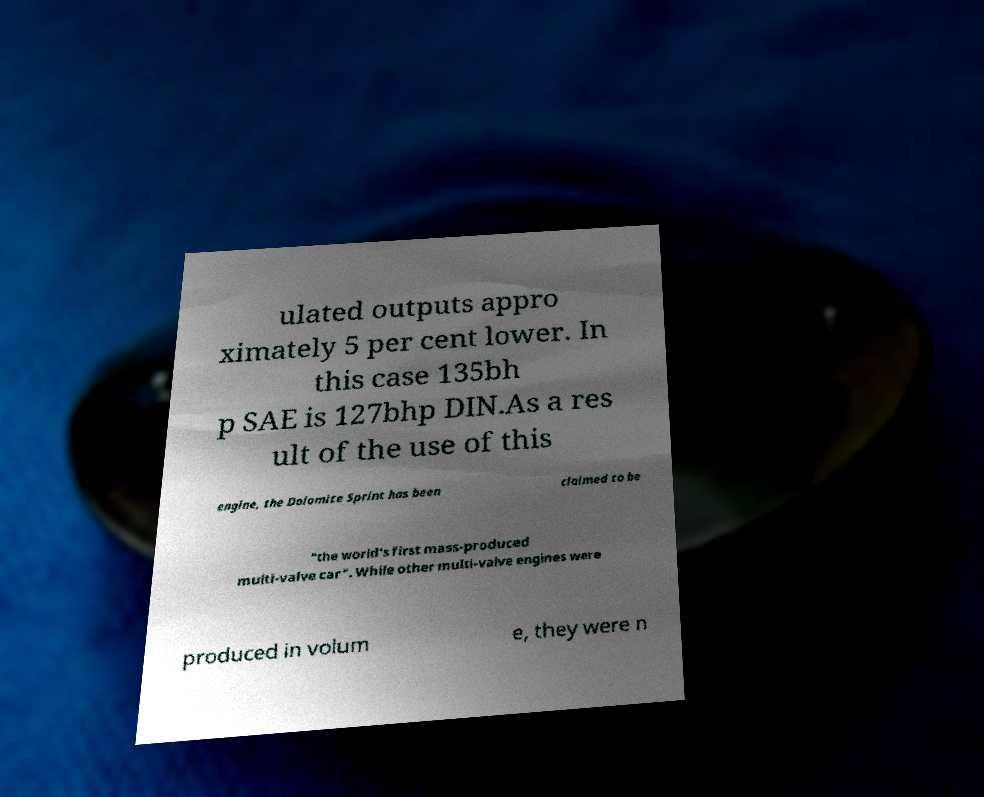There's text embedded in this image that I need extracted. Can you transcribe it verbatim? ulated outputs appro ximately 5 per cent lower. In this case 135bh p SAE is 127bhp DIN.As a res ult of the use of this engine, the Dolomite Sprint has been claimed to be "the world's first mass-produced multi-valve car". While other multi-valve engines were produced in volum e, they were n 